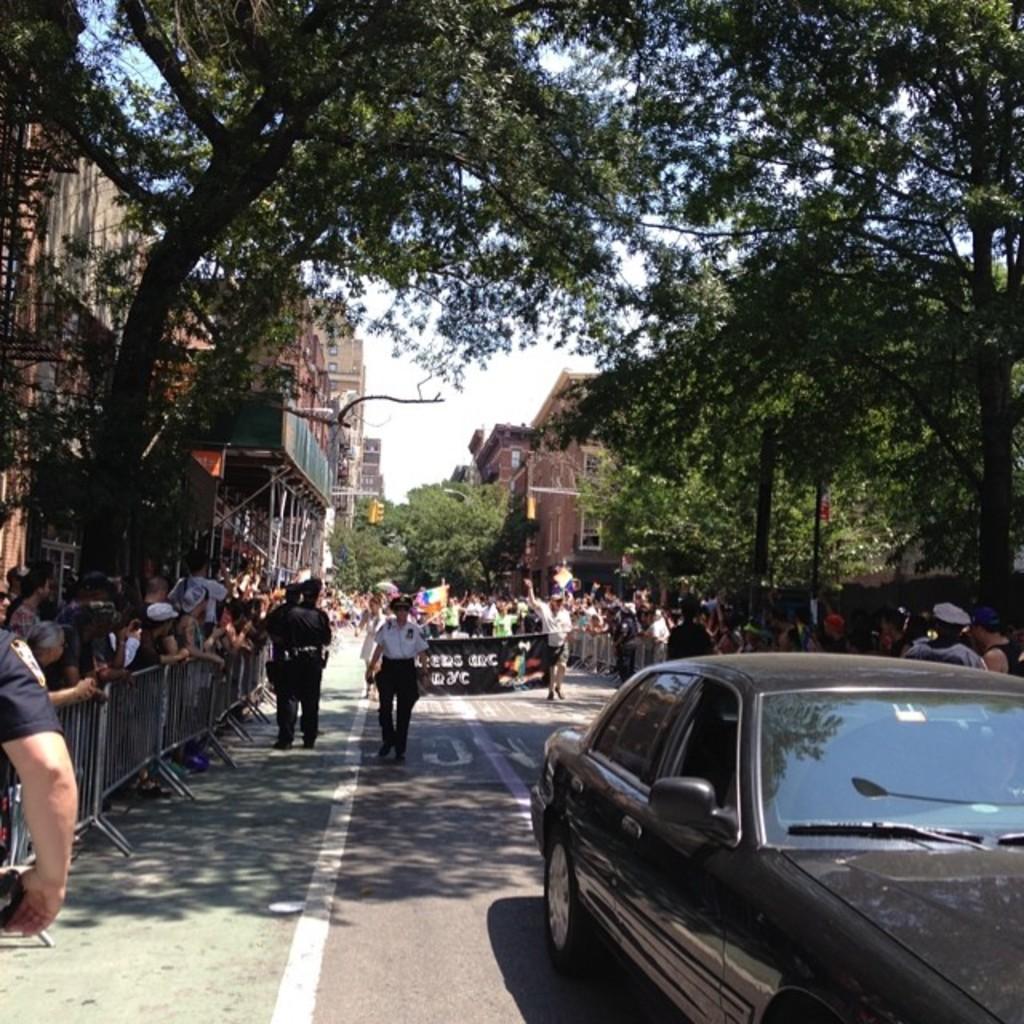How would you summarize this image in a sentence or two? In the center of the image we can see a group of people are walking on the road and some of them are holding the flags and two people are holding a banner. In the background of the image we can see the buildings, boards, trees and a group of people are standing. On the left side of the image we can see the barricades. At the bottom of the image we can see the road and car. At the top of the image we can see the sky. 